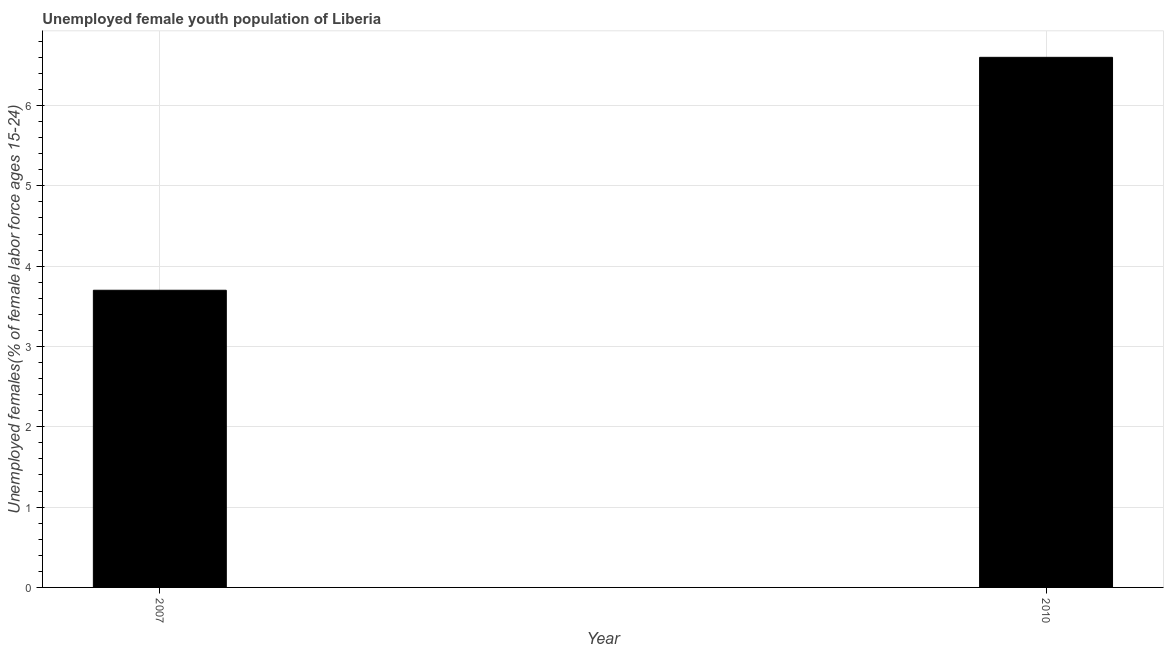Does the graph contain grids?
Ensure brevity in your answer.  Yes. What is the title of the graph?
Your answer should be compact. Unemployed female youth population of Liberia. What is the label or title of the X-axis?
Keep it short and to the point. Year. What is the label or title of the Y-axis?
Your answer should be very brief. Unemployed females(% of female labor force ages 15-24). What is the unemployed female youth in 2010?
Keep it short and to the point. 6.6. Across all years, what is the maximum unemployed female youth?
Keep it short and to the point. 6.6. Across all years, what is the minimum unemployed female youth?
Give a very brief answer. 3.7. In which year was the unemployed female youth minimum?
Make the answer very short. 2007. What is the sum of the unemployed female youth?
Provide a short and direct response. 10.3. What is the average unemployed female youth per year?
Your answer should be compact. 5.15. What is the median unemployed female youth?
Provide a short and direct response. 5.15. What is the ratio of the unemployed female youth in 2007 to that in 2010?
Offer a very short reply. 0.56. Are the values on the major ticks of Y-axis written in scientific E-notation?
Make the answer very short. No. What is the Unemployed females(% of female labor force ages 15-24) in 2007?
Your answer should be very brief. 3.7. What is the Unemployed females(% of female labor force ages 15-24) in 2010?
Make the answer very short. 6.6. What is the difference between the Unemployed females(% of female labor force ages 15-24) in 2007 and 2010?
Provide a short and direct response. -2.9. What is the ratio of the Unemployed females(% of female labor force ages 15-24) in 2007 to that in 2010?
Ensure brevity in your answer.  0.56. 